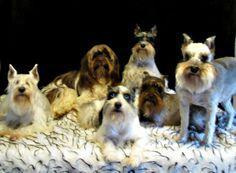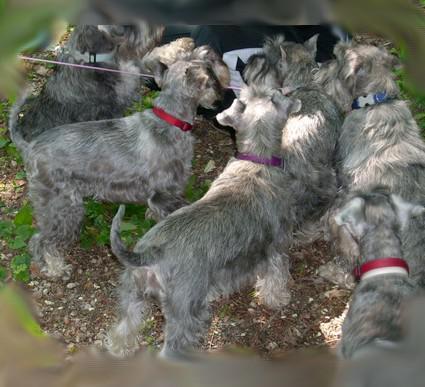The first image is the image on the left, the second image is the image on the right. For the images shown, is this caption "Right image shows a group of schnauzers wearing colored collars." true? Answer yes or no. Yes. 